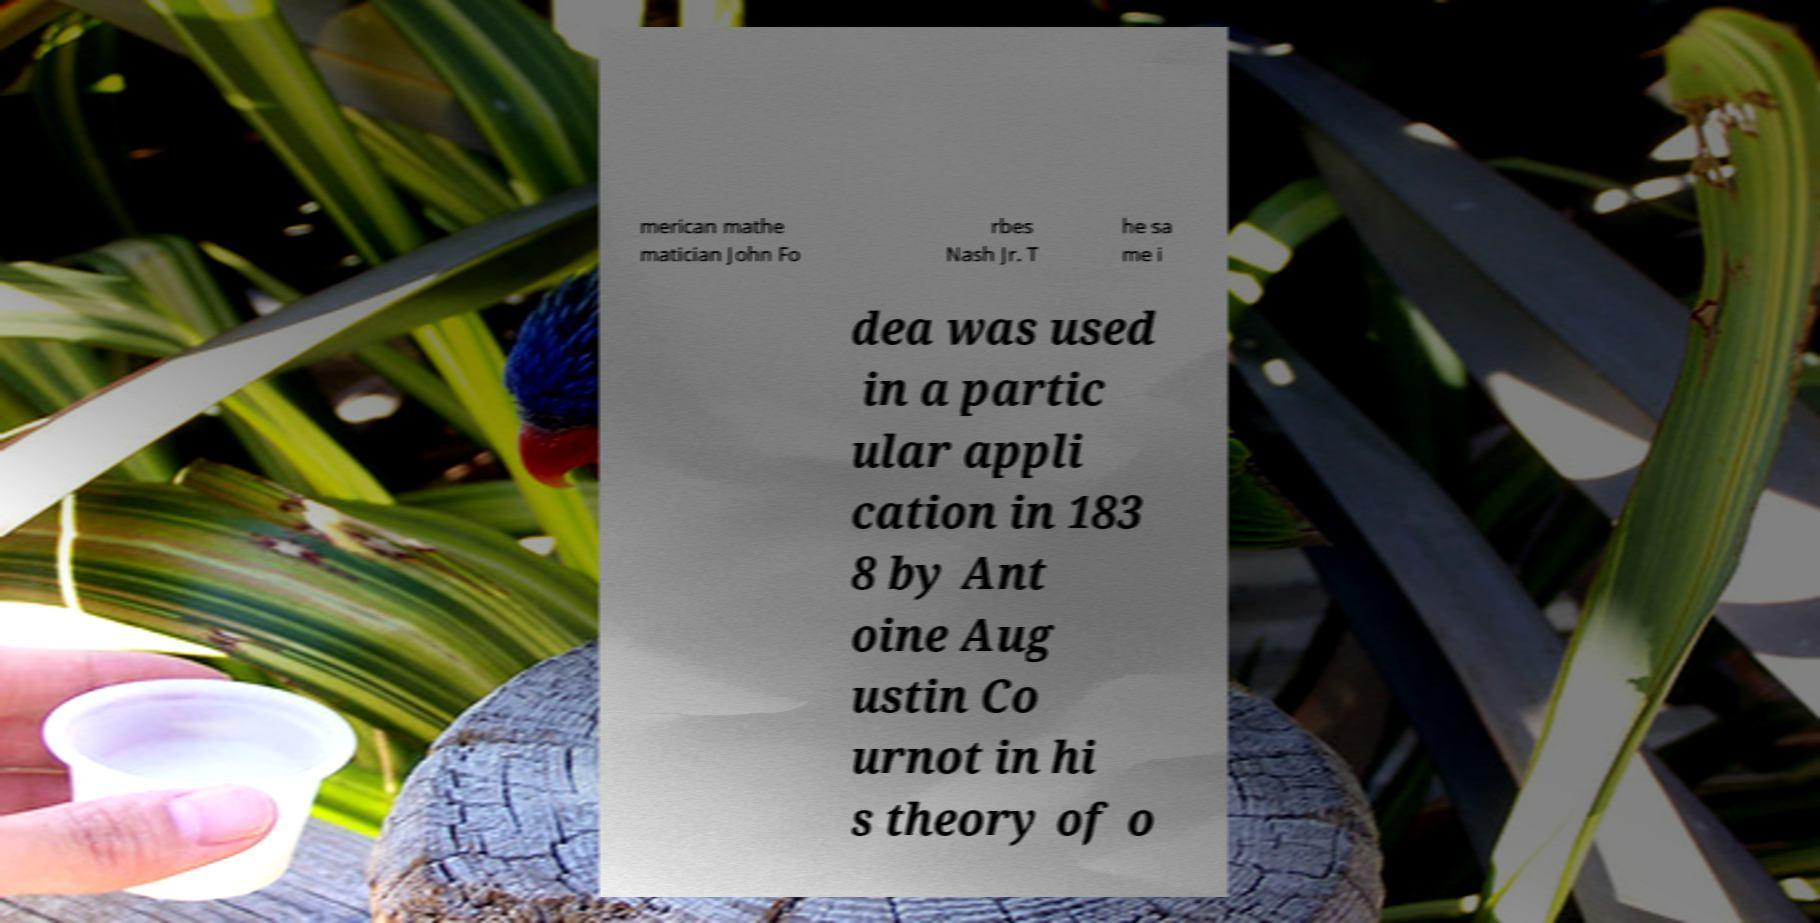There's text embedded in this image that I need extracted. Can you transcribe it verbatim? merican mathe matician John Fo rbes Nash Jr. T he sa me i dea was used in a partic ular appli cation in 183 8 by Ant oine Aug ustin Co urnot in hi s theory of o 